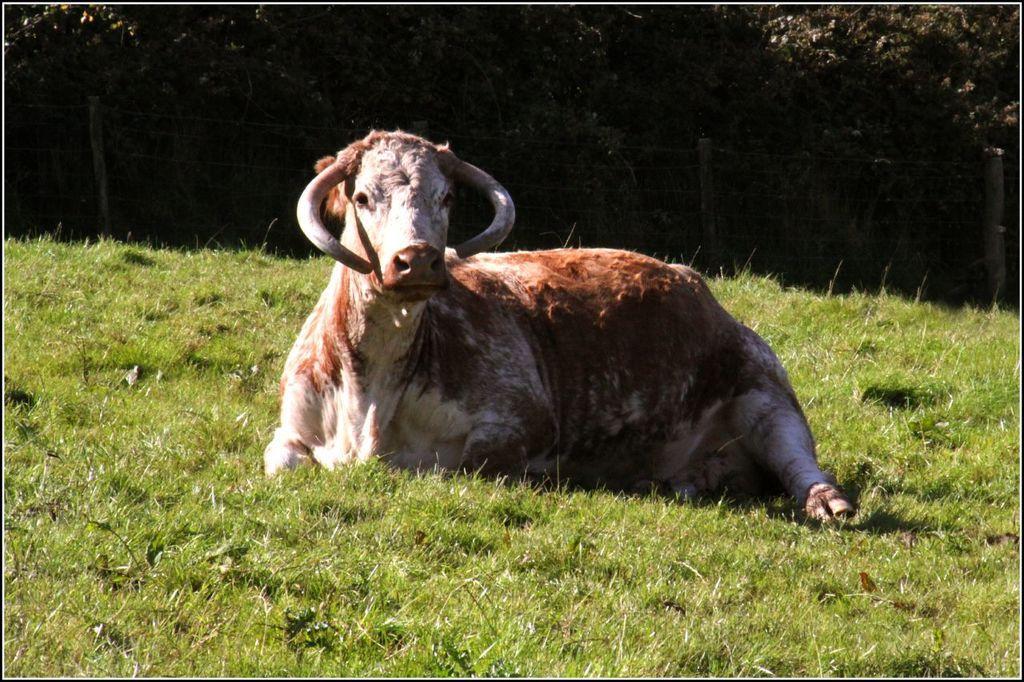Could you give a brief overview of what you see in this image? In the center of the image we can see an animal. In the background of the image we can see the grass. At the top of the image we can see the fencing and trees. 